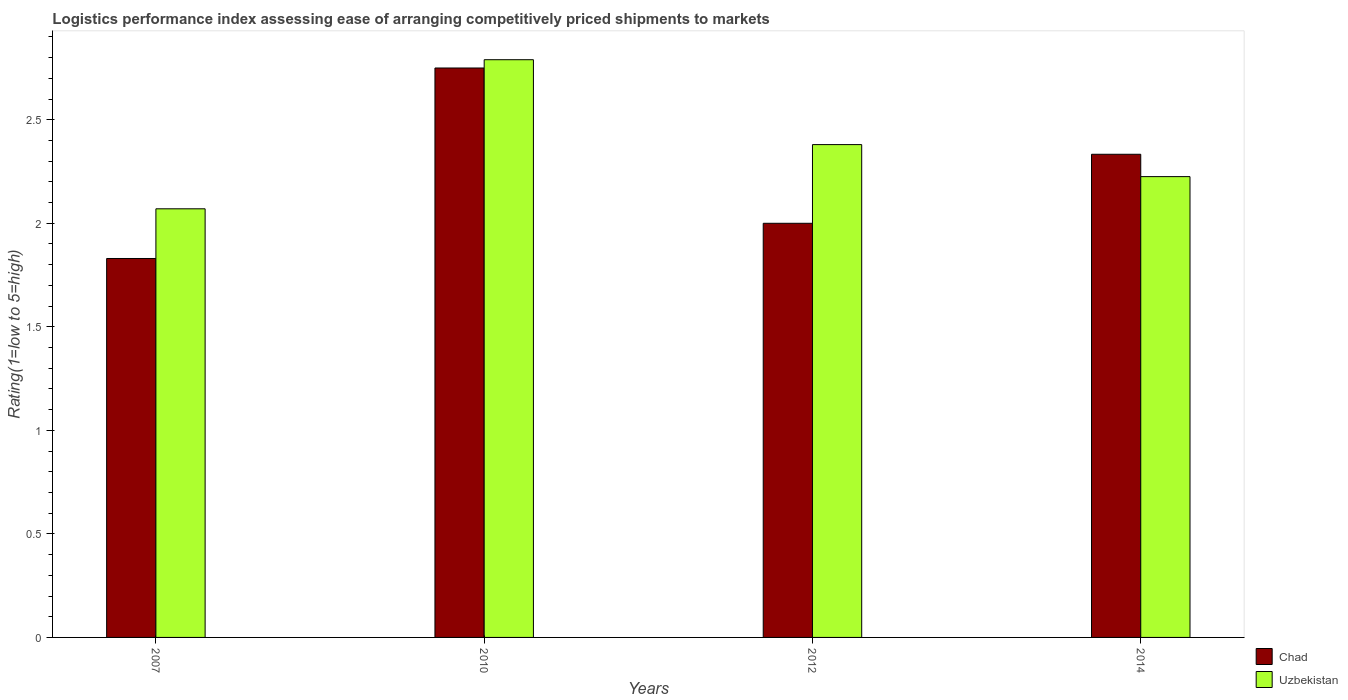How many different coloured bars are there?
Keep it short and to the point. 2. How many bars are there on the 1st tick from the left?
Your answer should be very brief. 2. What is the label of the 3rd group of bars from the left?
Keep it short and to the point. 2012. What is the Logistic performance index in Chad in 2010?
Give a very brief answer. 2.75. Across all years, what is the maximum Logistic performance index in Chad?
Offer a very short reply. 2.75. Across all years, what is the minimum Logistic performance index in Uzbekistan?
Keep it short and to the point. 2.07. In which year was the Logistic performance index in Chad maximum?
Provide a succinct answer. 2010. What is the total Logistic performance index in Chad in the graph?
Make the answer very short. 8.91. What is the difference between the Logistic performance index in Uzbekistan in 2010 and the Logistic performance index in Chad in 2014?
Your answer should be compact. 0.46. What is the average Logistic performance index in Uzbekistan per year?
Your answer should be compact. 2.37. In the year 2010, what is the difference between the Logistic performance index in Uzbekistan and Logistic performance index in Chad?
Make the answer very short. 0.04. What is the ratio of the Logistic performance index in Chad in 2007 to that in 2010?
Your answer should be compact. 0.67. Is the Logistic performance index in Uzbekistan in 2012 less than that in 2014?
Ensure brevity in your answer.  No. Is the difference between the Logistic performance index in Uzbekistan in 2010 and 2014 greater than the difference between the Logistic performance index in Chad in 2010 and 2014?
Your response must be concise. Yes. What is the difference between the highest and the second highest Logistic performance index in Chad?
Your response must be concise. 0.42. What is the difference between the highest and the lowest Logistic performance index in Uzbekistan?
Keep it short and to the point. 0.72. Is the sum of the Logistic performance index in Chad in 2007 and 2010 greater than the maximum Logistic performance index in Uzbekistan across all years?
Offer a very short reply. Yes. What does the 1st bar from the left in 2010 represents?
Offer a very short reply. Chad. What does the 1st bar from the right in 2012 represents?
Your answer should be compact. Uzbekistan. Does the graph contain any zero values?
Keep it short and to the point. No. Does the graph contain grids?
Make the answer very short. No. How are the legend labels stacked?
Make the answer very short. Vertical. What is the title of the graph?
Make the answer very short. Logistics performance index assessing ease of arranging competitively priced shipments to markets. What is the label or title of the Y-axis?
Offer a terse response. Rating(1=low to 5=high). What is the Rating(1=low to 5=high) in Chad in 2007?
Your answer should be very brief. 1.83. What is the Rating(1=low to 5=high) of Uzbekistan in 2007?
Your answer should be very brief. 2.07. What is the Rating(1=low to 5=high) of Chad in 2010?
Your response must be concise. 2.75. What is the Rating(1=low to 5=high) in Uzbekistan in 2010?
Your answer should be very brief. 2.79. What is the Rating(1=low to 5=high) of Chad in 2012?
Ensure brevity in your answer.  2. What is the Rating(1=low to 5=high) of Uzbekistan in 2012?
Your answer should be very brief. 2.38. What is the Rating(1=low to 5=high) of Chad in 2014?
Make the answer very short. 2.33. What is the Rating(1=low to 5=high) in Uzbekistan in 2014?
Keep it short and to the point. 2.23. Across all years, what is the maximum Rating(1=low to 5=high) of Chad?
Provide a short and direct response. 2.75. Across all years, what is the maximum Rating(1=low to 5=high) of Uzbekistan?
Your answer should be very brief. 2.79. Across all years, what is the minimum Rating(1=low to 5=high) in Chad?
Keep it short and to the point. 1.83. Across all years, what is the minimum Rating(1=low to 5=high) in Uzbekistan?
Ensure brevity in your answer.  2.07. What is the total Rating(1=low to 5=high) of Chad in the graph?
Keep it short and to the point. 8.91. What is the total Rating(1=low to 5=high) in Uzbekistan in the graph?
Provide a succinct answer. 9.47. What is the difference between the Rating(1=low to 5=high) in Chad in 2007 and that in 2010?
Keep it short and to the point. -0.92. What is the difference between the Rating(1=low to 5=high) in Uzbekistan in 2007 and that in 2010?
Provide a succinct answer. -0.72. What is the difference between the Rating(1=low to 5=high) in Chad in 2007 and that in 2012?
Keep it short and to the point. -0.17. What is the difference between the Rating(1=low to 5=high) of Uzbekistan in 2007 and that in 2012?
Make the answer very short. -0.31. What is the difference between the Rating(1=low to 5=high) in Chad in 2007 and that in 2014?
Make the answer very short. -0.5. What is the difference between the Rating(1=low to 5=high) of Uzbekistan in 2007 and that in 2014?
Provide a short and direct response. -0.16. What is the difference between the Rating(1=low to 5=high) of Chad in 2010 and that in 2012?
Keep it short and to the point. 0.75. What is the difference between the Rating(1=low to 5=high) in Uzbekistan in 2010 and that in 2012?
Your answer should be very brief. 0.41. What is the difference between the Rating(1=low to 5=high) in Chad in 2010 and that in 2014?
Give a very brief answer. 0.42. What is the difference between the Rating(1=low to 5=high) of Uzbekistan in 2010 and that in 2014?
Offer a very short reply. 0.56. What is the difference between the Rating(1=low to 5=high) of Uzbekistan in 2012 and that in 2014?
Your answer should be very brief. 0.15. What is the difference between the Rating(1=low to 5=high) of Chad in 2007 and the Rating(1=low to 5=high) of Uzbekistan in 2010?
Ensure brevity in your answer.  -0.96. What is the difference between the Rating(1=low to 5=high) of Chad in 2007 and the Rating(1=low to 5=high) of Uzbekistan in 2012?
Keep it short and to the point. -0.55. What is the difference between the Rating(1=low to 5=high) of Chad in 2007 and the Rating(1=low to 5=high) of Uzbekistan in 2014?
Give a very brief answer. -0.4. What is the difference between the Rating(1=low to 5=high) in Chad in 2010 and the Rating(1=low to 5=high) in Uzbekistan in 2012?
Your answer should be very brief. 0.37. What is the difference between the Rating(1=low to 5=high) of Chad in 2010 and the Rating(1=low to 5=high) of Uzbekistan in 2014?
Provide a short and direct response. 0.52. What is the difference between the Rating(1=low to 5=high) of Chad in 2012 and the Rating(1=low to 5=high) of Uzbekistan in 2014?
Your answer should be very brief. -0.23. What is the average Rating(1=low to 5=high) in Chad per year?
Your answer should be compact. 2.23. What is the average Rating(1=low to 5=high) of Uzbekistan per year?
Your answer should be very brief. 2.37. In the year 2007, what is the difference between the Rating(1=low to 5=high) in Chad and Rating(1=low to 5=high) in Uzbekistan?
Your response must be concise. -0.24. In the year 2010, what is the difference between the Rating(1=low to 5=high) in Chad and Rating(1=low to 5=high) in Uzbekistan?
Offer a very short reply. -0.04. In the year 2012, what is the difference between the Rating(1=low to 5=high) in Chad and Rating(1=low to 5=high) in Uzbekistan?
Offer a terse response. -0.38. In the year 2014, what is the difference between the Rating(1=low to 5=high) of Chad and Rating(1=low to 5=high) of Uzbekistan?
Offer a very short reply. 0.11. What is the ratio of the Rating(1=low to 5=high) in Chad in 2007 to that in 2010?
Provide a short and direct response. 0.67. What is the ratio of the Rating(1=low to 5=high) in Uzbekistan in 2007 to that in 2010?
Give a very brief answer. 0.74. What is the ratio of the Rating(1=low to 5=high) of Chad in 2007 to that in 2012?
Provide a succinct answer. 0.92. What is the ratio of the Rating(1=low to 5=high) of Uzbekistan in 2007 to that in 2012?
Your response must be concise. 0.87. What is the ratio of the Rating(1=low to 5=high) in Chad in 2007 to that in 2014?
Provide a succinct answer. 0.78. What is the ratio of the Rating(1=low to 5=high) in Uzbekistan in 2007 to that in 2014?
Give a very brief answer. 0.93. What is the ratio of the Rating(1=low to 5=high) of Chad in 2010 to that in 2012?
Ensure brevity in your answer.  1.38. What is the ratio of the Rating(1=low to 5=high) in Uzbekistan in 2010 to that in 2012?
Ensure brevity in your answer.  1.17. What is the ratio of the Rating(1=low to 5=high) in Chad in 2010 to that in 2014?
Ensure brevity in your answer.  1.18. What is the ratio of the Rating(1=low to 5=high) in Uzbekistan in 2010 to that in 2014?
Provide a short and direct response. 1.25. What is the ratio of the Rating(1=low to 5=high) in Chad in 2012 to that in 2014?
Your answer should be compact. 0.86. What is the ratio of the Rating(1=low to 5=high) of Uzbekistan in 2012 to that in 2014?
Ensure brevity in your answer.  1.07. What is the difference between the highest and the second highest Rating(1=low to 5=high) of Chad?
Your response must be concise. 0.42. What is the difference between the highest and the second highest Rating(1=low to 5=high) of Uzbekistan?
Provide a succinct answer. 0.41. What is the difference between the highest and the lowest Rating(1=low to 5=high) in Uzbekistan?
Your response must be concise. 0.72. 